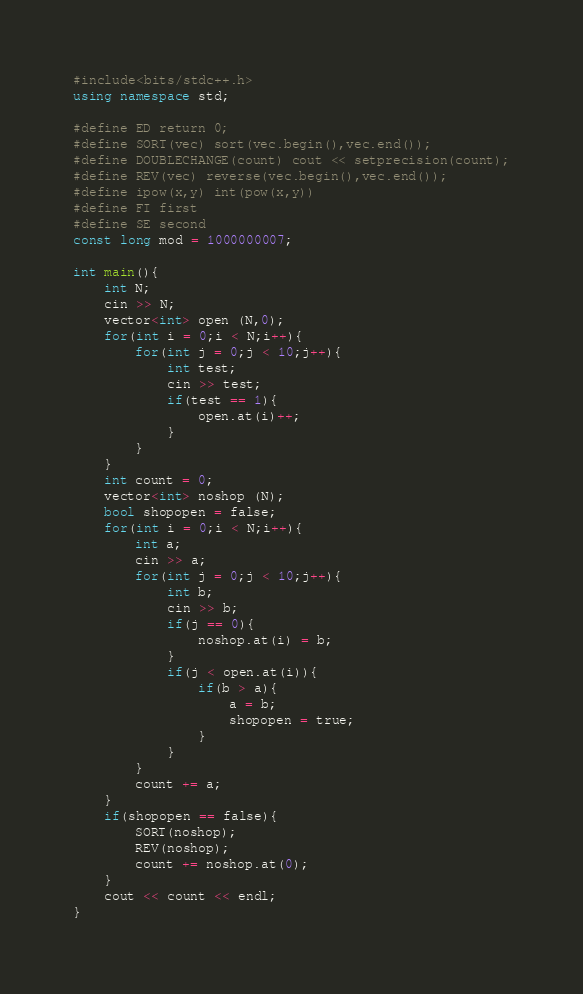Convert code to text. <code><loc_0><loc_0><loc_500><loc_500><_C++_>#include<bits/stdc++.h>
using namespace std;

#define ED return 0;
#define SORT(vec) sort(vec.begin(),vec.end());
#define DOUBLECHANGE(count) cout << setprecision(count);
#define REV(vec) reverse(vec.begin(),vec.end());
#define ipow(x,y) int(pow(x,y))
#define FI first
#define SE second
const long mod = 1000000007;

int main(){
    int N;
    cin >> N;
    vector<int> open (N,0);
    for(int i = 0;i < N;i++){
        for(int j = 0;j < 10;j++){
            int test;
            cin >> test;
            if(test == 1){
                open.at(i)++;
            }
        }
    }
    int count = 0;
    vector<int> noshop (N);
    bool shopopen = false;
    for(int i = 0;i < N;i++){
        int a;
        cin >> a;
        for(int j = 0;j < 10;j++){
            int b;
            cin >> b;
            if(j == 0){
                noshop.at(i) = b;
            }
            if(j < open.at(i)){
                if(b > a){
                    a = b;
                    shopopen = true;
                }
            }
        }
        count += a;
    }
    if(shopopen == false){
        SORT(noshop);
        REV(noshop);
        count += noshop.at(0);
    }
    cout << count << endl;
}
</code> 